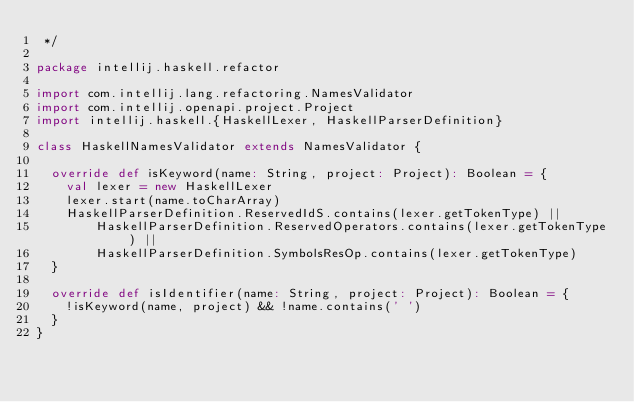<code> <loc_0><loc_0><loc_500><loc_500><_Scala_> */

package intellij.haskell.refactor

import com.intellij.lang.refactoring.NamesValidator
import com.intellij.openapi.project.Project
import intellij.haskell.{HaskellLexer, HaskellParserDefinition}

class HaskellNamesValidator extends NamesValidator {

  override def isKeyword(name: String, project: Project): Boolean = {
    val lexer = new HaskellLexer
    lexer.start(name.toCharArray)
    HaskellParserDefinition.ReservedIdS.contains(lexer.getTokenType) ||
        HaskellParserDefinition.ReservedOperators.contains(lexer.getTokenType) ||
        HaskellParserDefinition.SymbolsResOp.contains(lexer.getTokenType)
  }

  override def isIdentifier(name: String, project: Project): Boolean = {
    !isKeyword(name, project) && !name.contains(' ')
  }
}
</code> 